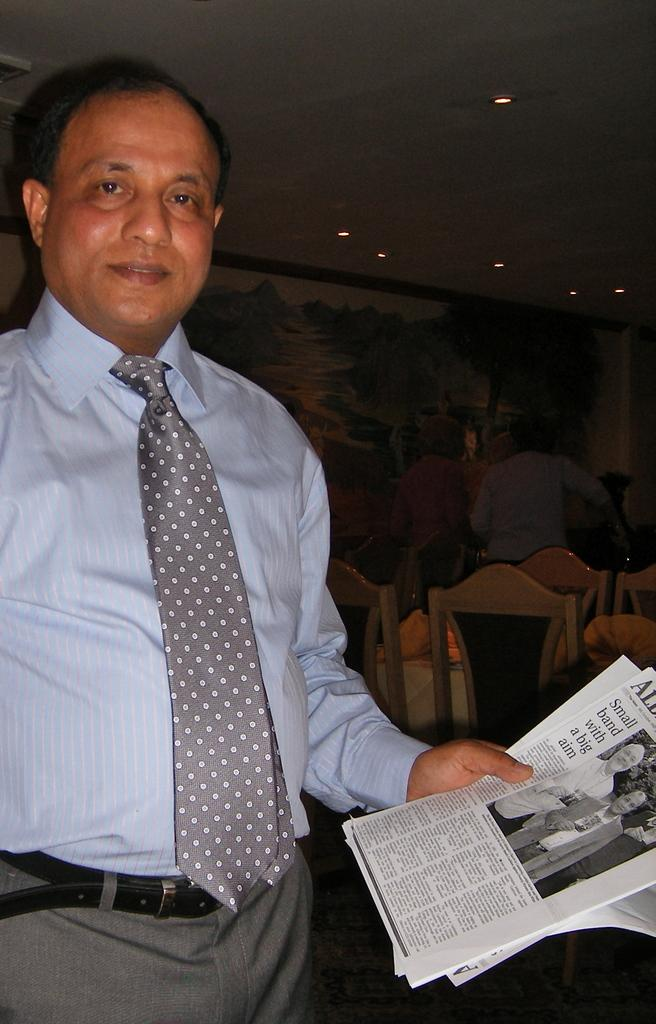How many people are in the image? There are people in the image, but the exact number is not specified. What is one person holding in the image? One person is holding posters with text and images in the image. What type of furniture is present in the image? There are chairs in the image. What is the background of the image? There is a wall in the image, and the roof is visible. What is on the roof in the image? There are lights on the roof in the image. Can you describe the clouds visible in the image? There are no clouds visible in the image; the roof and lights are mentioned, but no clouds are described. 